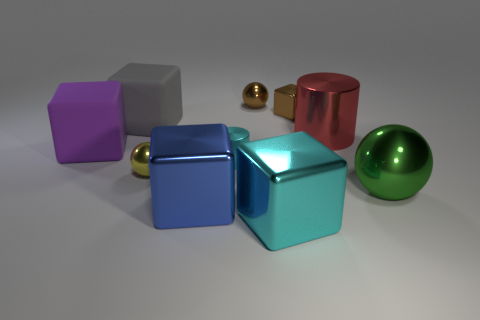Does the small cylinder have the same color as the large metallic block to the right of the blue shiny block?
Your answer should be very brief. Yes. The metallic object that is the same color as the small cylinder is what size?
Ensure brevity in your answer.  Large. Is there a small shiny object that has the same color as the small metal cube?
Provide a short and direct response. Yes. There is a metal cube that is to the left of the large cyan shiny thing; what number of big cubes are behind it?
Your response must be concise. 2. How many objects are big metallic objects on the right side of the tiny brown sphere or big yellow metal things?
Your answer should be very brief. 3. What number of large cubes are the same material as the large gray object?
Offer a terse response. 1. What is the shape of the metal object that is the same color as the tiny shiny cube?
Offer a terse response. Sphere. Are there an equal number of cyan metallic things in front of the tiny yellow object and brown metallic objects?
Provide a succinct answer. No. There is a cyan metal object that is behind the blue block; how big is it?
Your answer should be compact. Small. What number of tiny things are either red metal things or green metal things?
Your answer should be very brief. 0. 